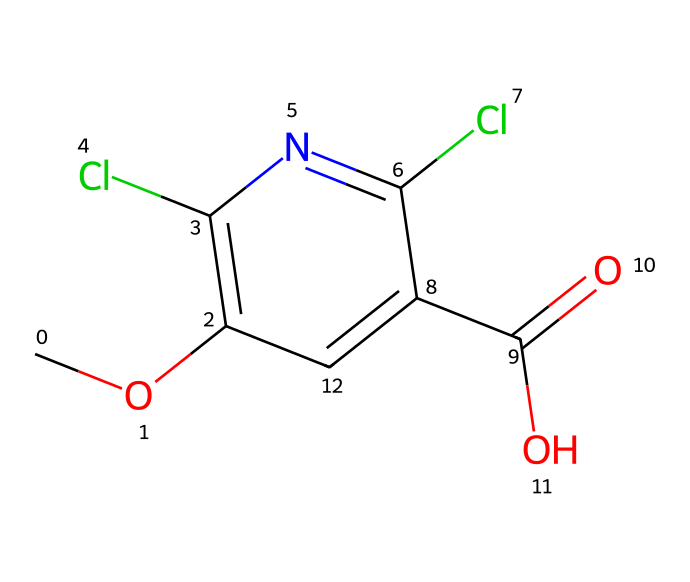What is the name of this chemical? The chemical structure corresponds to dicamba, which is identified based on its common use in herbicides and its unique structure as represented in the SMILES notation.
Answer: dicamba How many chlorine atoms are in the structure? The provided SMILES notation indicates the presence of two chlorine atoms, represented explicitly in the structure by "Cl," which is counted directly from the notation.
Answer: two What functional group is present in the chemical? The chemical contains a carboxylic acid functional group, as indicated by the presence of "C(=O)O" in the structure, which is characteristic of this group.
Answer: carboxylic acid What is the total number of carbon atoms in the structure? By analyzing the SMILES representation, there are five carbon atoms present ("C") including those in the carboxylic acid and other parts of the structure, indicating a total of five.
Answer: five Is this chemical more effective against broadleaf or grass weeds? Dicamba is considered a selective herbicide primarily effective against broadleaf weeds, as inferred from its specific chemical structure and mode of action.
Answer: broadleaf What is the significance of the methoxy group in the structure? The methoxy group ("CO") contributes to the herbicidal activity of dicamba, enhancing its ability to penetrate plant tissues and thus increasing its effectiveness as a herbicide.
Answer: enhances penetration What role do the nitrogen atoms play in this herbicide? The nitrogen in the structure contributes to the chemical's ability to interfere with plant growth regulators, making dicamba effective in controlling unwanted vegetation.
Answer: interference with growth regulators 